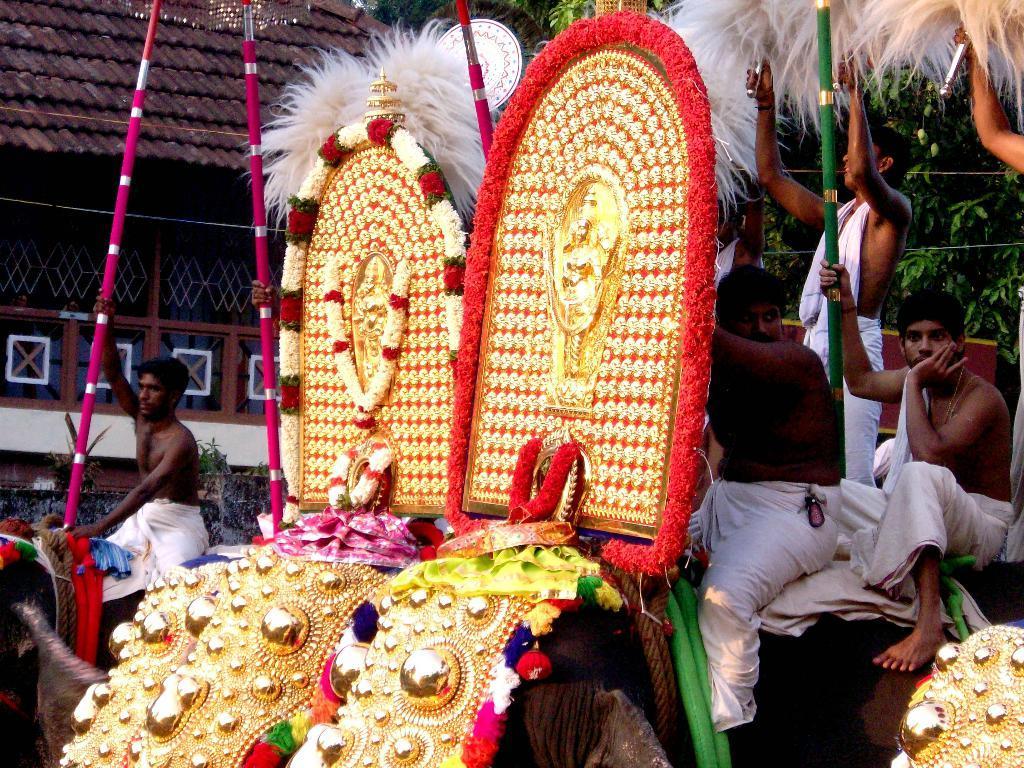How would you summarize this image in a sentence or two? In the center of the image we can see a two sculptures of elephants. On the right side of the image we can see a stick and persons and trees. On the left side of the image we can see man sitting on the elephant with stick. In the background there is a building and trees. 